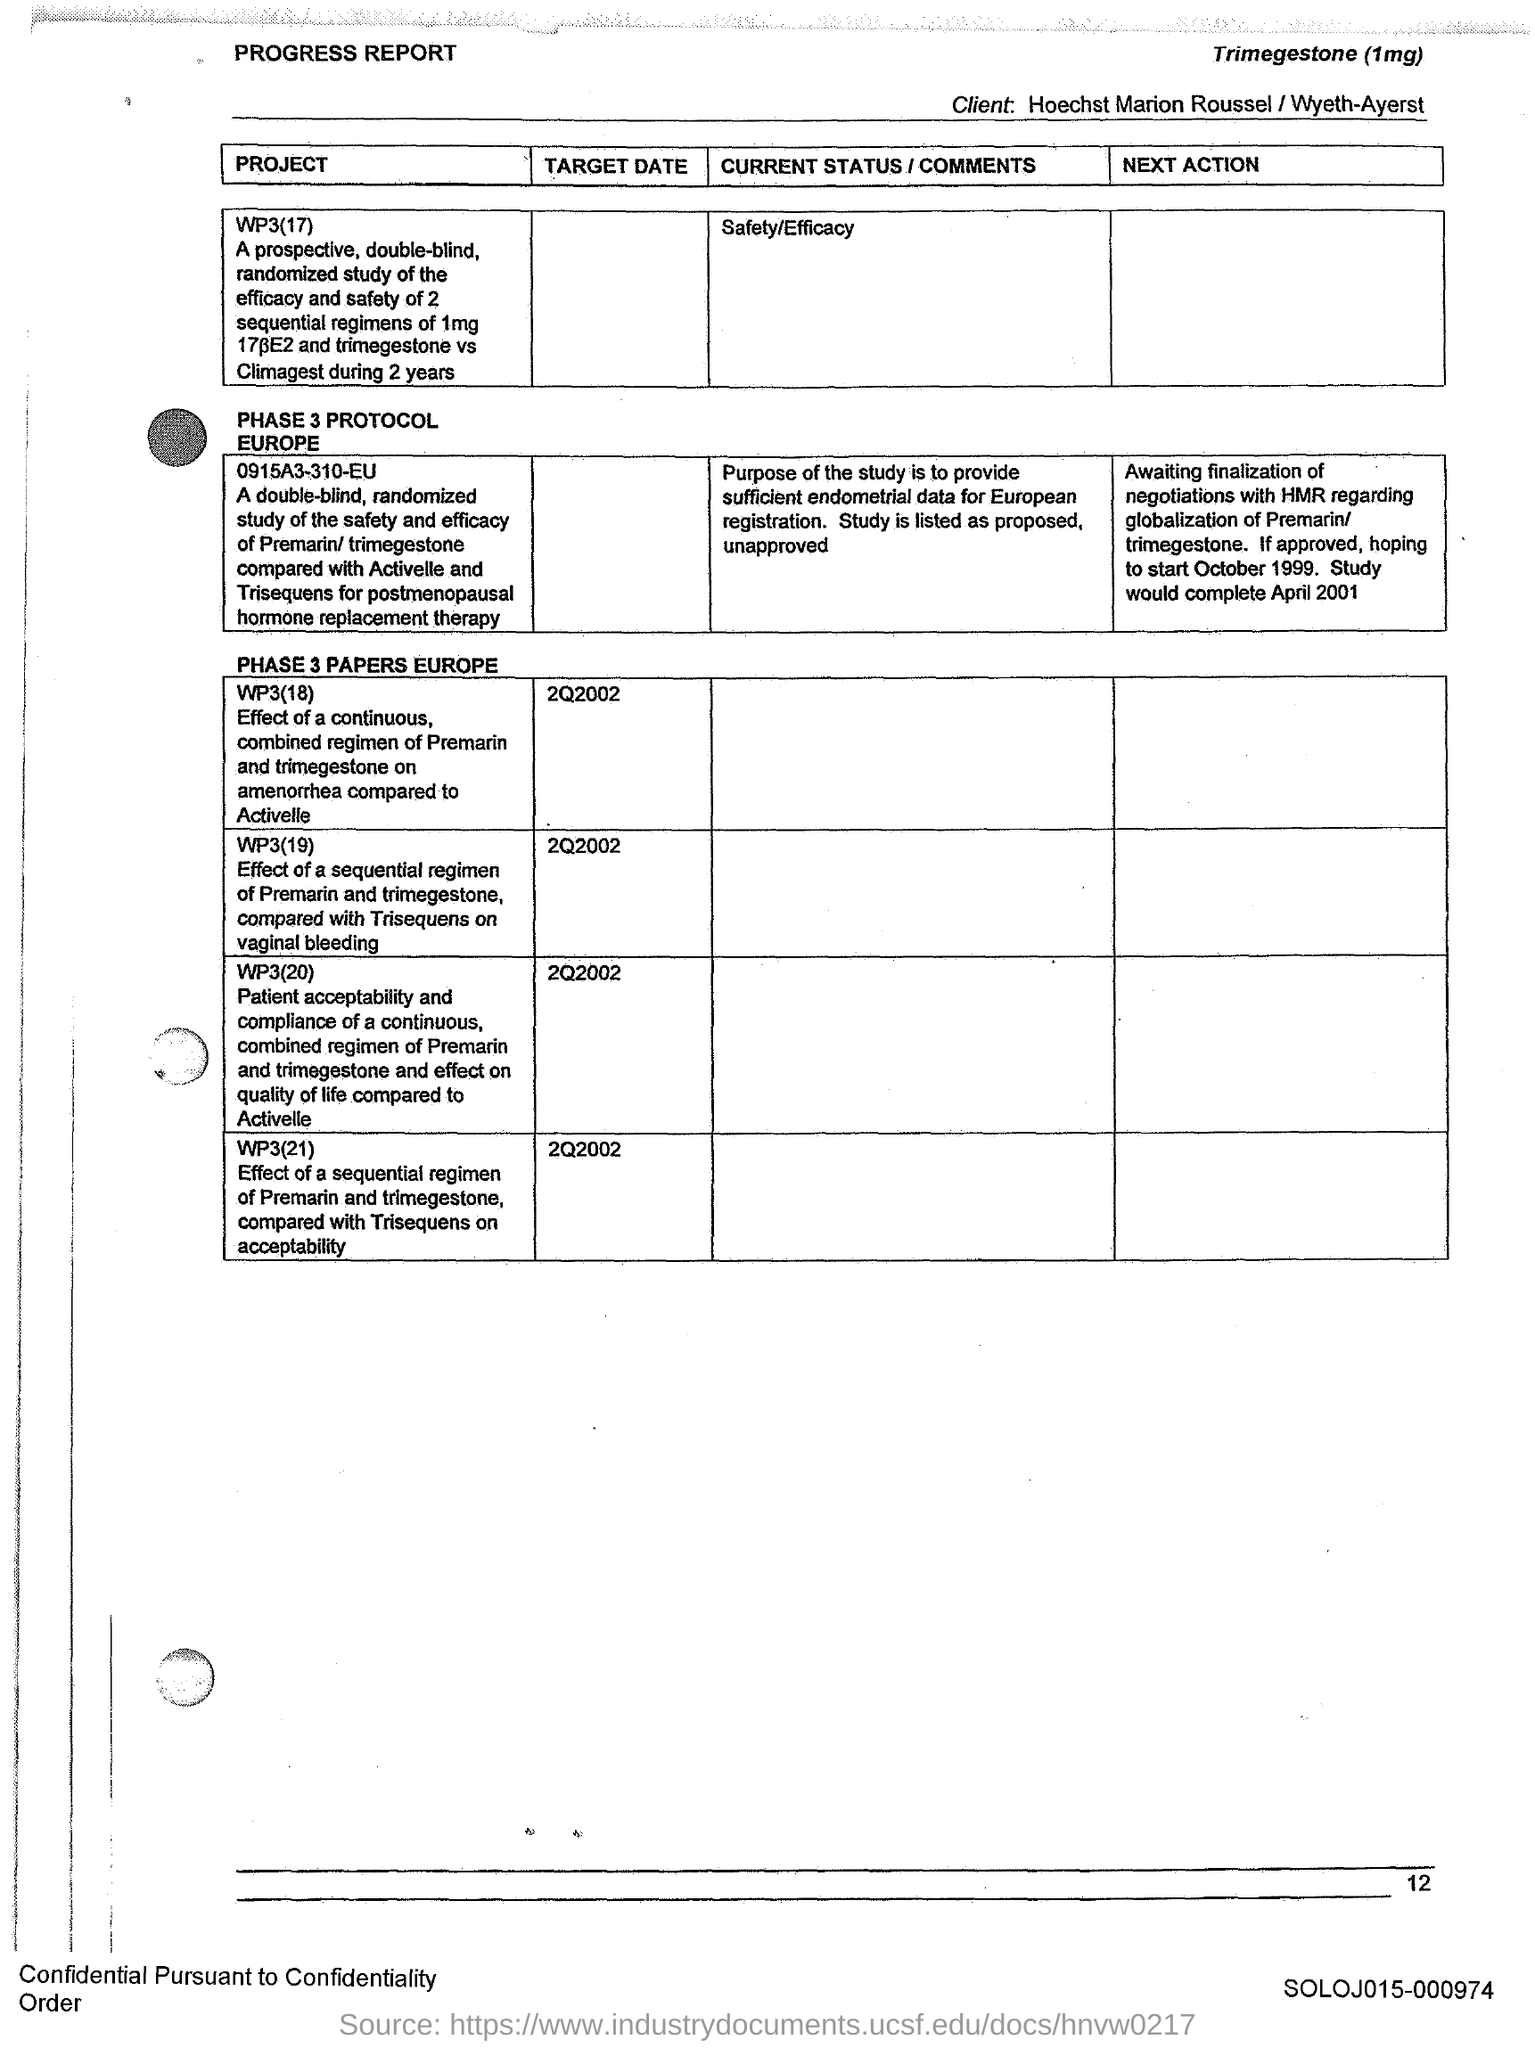Mention a couple of crucial points in this snapshot. The text located at the top-right corner of the document is "Which text is at the top-right of the document? Trimegestone (1mg)..". The text that is located at the top-left corner of the document is "Progress Report.. 